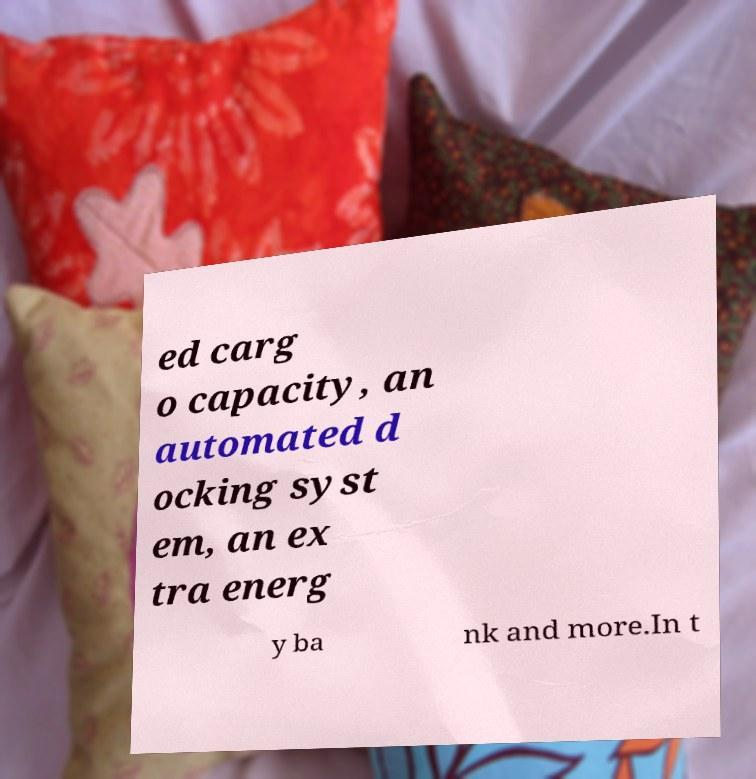Please read and relay the text visible in this image. What does it say? ed carg o capacity, an automated d ocking syst em, an ex tra energ y ba nk and more.In t 